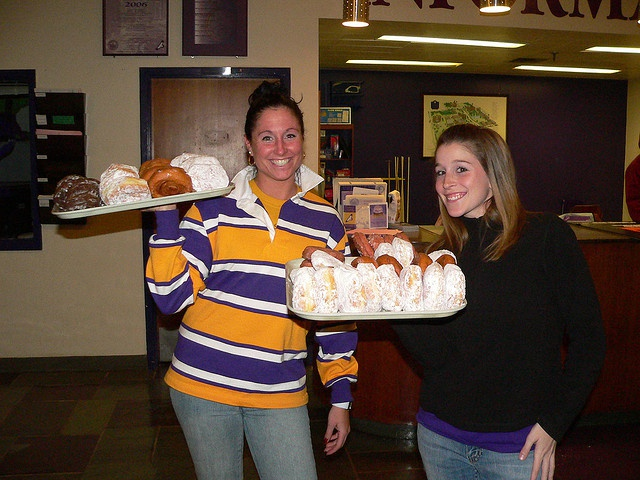Describe the objects in this image and their specific colors. I can see people in darkgreen, orange, gray, navy, and lightgray tones, people in darkgreen, black, gray, maroon, and navy tones, donut in darkgreen, lightgray, brown, and tan tones, donut in darkgreen, white, and tan tones, and donut in darkgreen, maroon, black, and gray tones in this image. 